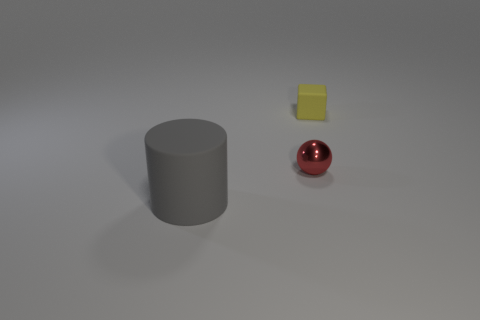There is a yellow thing that is the same size as the red metal thing; what is its shape?
Your response must be concise. Cube. There is a large cylinder; is its color the same as the small object to the left of the tiny yellow matte object?
Your answer should be very brief. No. There is a matte thing that is right of the shiny ball; what number of yellow rubber objects are in front of it?
Your answer should be compact. 0. How big is the thing that is left of the tiny matte block and to the right of the big gray cylinder?
Keep it short and to the point. Small. Is there a matte block of the same size as the shiny thing?
Offer a very short reply. Yes. Are there more tiny rubber blocks right of the small yellow block than gray rubber things on the right side of the cylinder?
Make the answer very short. No. Do the block and the tiny object that is left of the tiny yellow matte block have the same material?
Offer a terse response. No. What number of big gray objects are to the left of the matte object that is to the right of the thing that is in front of the small sphere?
Provide a short and direct response. 1. Does the tiny yellow thing have the same shape as the small object that is on the left side of the yellow thing?
Make the answer very short. No. What is the color of the object that is both behind the large rubber cylinder and in front of the tiny rubber cube?
Give a very brief answer. Red. 